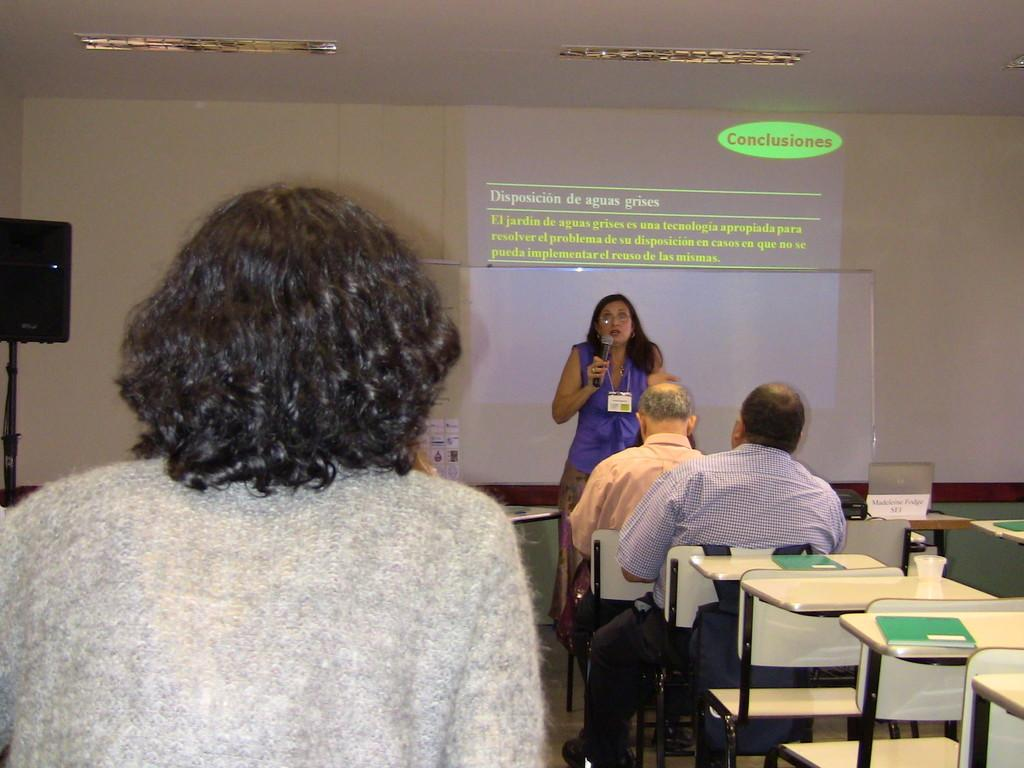What are the people in the image doing? The people in the image are sitting on chairs. What is the woman in the image doing? The woman is standing and holding a mic. What can be seen on the wall in the background of the image? There is a projector screen on a wall in the background of the image. What type of vacation is the woman planning based on the image? There is no indication of a vacation in the image; it shows a woman standing with a mic and people sitting on chairs. 